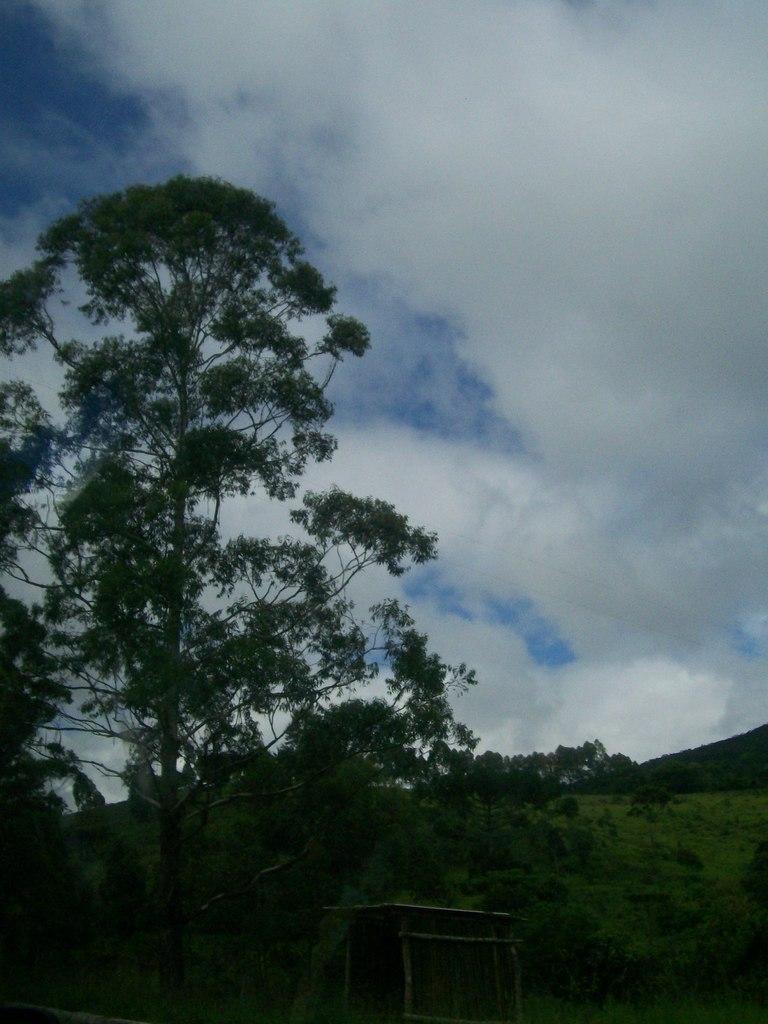In one or two sentences, can you explain what this image depicts? In this image, we can see a shed on the ground and in the background, there are trees. At the top, there are clouds in the sky. 